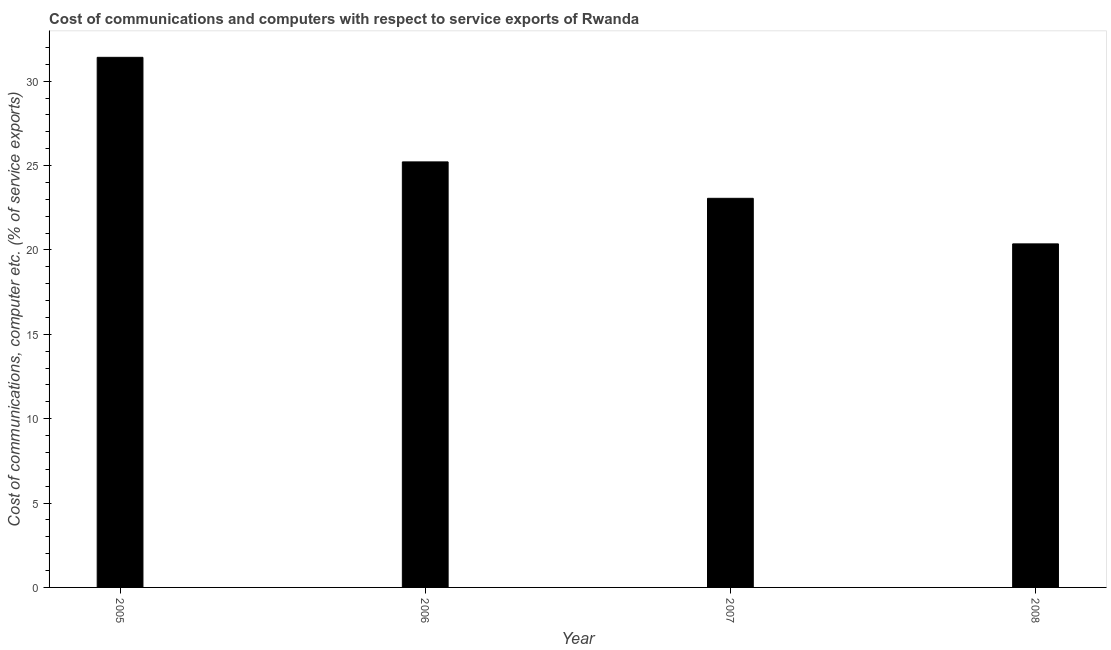What is the title of the graph?
Provide a short and direct response. Cost of communications and computers with respect to service exports of Rwanda. What is the label or title of the Y-axis?
Give a very brief answer. Cost of communications, computer etc. (% of service exports). What is the cost of communications and computer in 2005?
Your response must be concise. 31.41. Across all years, what is the maximum cost of communications and computer?
Offer a very short reply. 31.41. Across all years, what is the minimum cost of communications and computer?
Offer a terse response. 20.36. In which year was the cost of communications and computer maximum?
Make the answer very short. 2005. What is the sum of the cost of communications and computer?
Your answer should be compact. 100.05. What is the average cost of communications and computer per year?
Offer a very short reply. 25.01. What is the median cost of communications and computer?
Keep it short and to the point. 24.14. Do a majority of the years between 2008 and 2007 (inclusive) have cost of communications and computer greater than 15 %?
Offer a very short reply. No. What is the ratio of the cost of communications and computer in 2007 to that in 2008?
Offer a very short reply. 1.13. What is the difference between the highest and the second highest cost of communications and computer?
Your answer should be very brief. 6.2. Is the sum of the cost of communications and computer in 2006 and 2007 greater than the maximum cost of communications and computer across all years?
Make the answer very short. Yes. What is the difference between the highest and the lowest cost of communications and computer?
Provide a short and direct response. 11.06. How many bars are there?
Your answer should be compact. 4. What is the difference between two consecutive major ticks on the Y-axis?
Provide a succinct answer. 5. What is the Cost of communications, computer etc. (% of service exports) of 2005?
Your answer should be compact. 31.41. What is the Cost of communications, computer etc. (% of service exports) of 2006?
Provide a succinct answer. 25.22. What is the Cost of communications, computer etc. (% of service exports) of 2007?
Ensure brevity in your answer.  23.06. What is the Cost of communications, computer etc. (% of service exports) of 2008?
Your answer should be very brief. 20.36. What is the difference between the Cost of communications, computer etc. (% of service exports) in 2005 and 2006?
Your answer should be very brief. 6.2. What is the difference between the Cost of communications, computer etc. (% of service exports) in 2005 and 2007?
Give a very brief answer. 8.36. What is the difference between the Cost of communications, computer etc. (% of service exports) in 2005 and 2008?
Provide a short and direct response. 11.06. What is the difference between the Cost of communications, computer etc. (% of service exports) in 2006 and 2007?
Offer a very short reply. 2.16. What is the difference between the Cost of communications, computer etc. (% of service exports) in 2006 and 2008?
Give a very brief answer. 4.86. What is the difference between the Cost of communications, computer etc. (% of service exports) in 2007 and 2008?
Your response must be concise. 2.7. What is the ratio of the Cost of communications, computer etc. (% of service exports) in 2005 to that in 2006?
Your answer should be very brief. 1.25. What is the ratio of the Cost of communications, computer etc. (% of service exports) in 2005 to that in 2007?
Give a very brief answer. 1.36. What is the ratio of the Cost of communications, computer etc. (% of service exports) in 2005 to that in 2008?
Your response must be concise. 1.54. What is the ratio of the Cost of communications, computer etc. (% of service exports) in 2006 to that in 2007?
Ensure brevity in your answer.  1.09. What is the ratio of the Cost of communications, computer etc. (% of service exports) in 2006 to that in 2008?
Keep it short and to the point. 1.24. What is the ratio of the Cost of communications, computer etc. (% of service exports) in 2007 to that in 2008?
Offer a very short reply. 1.13. 